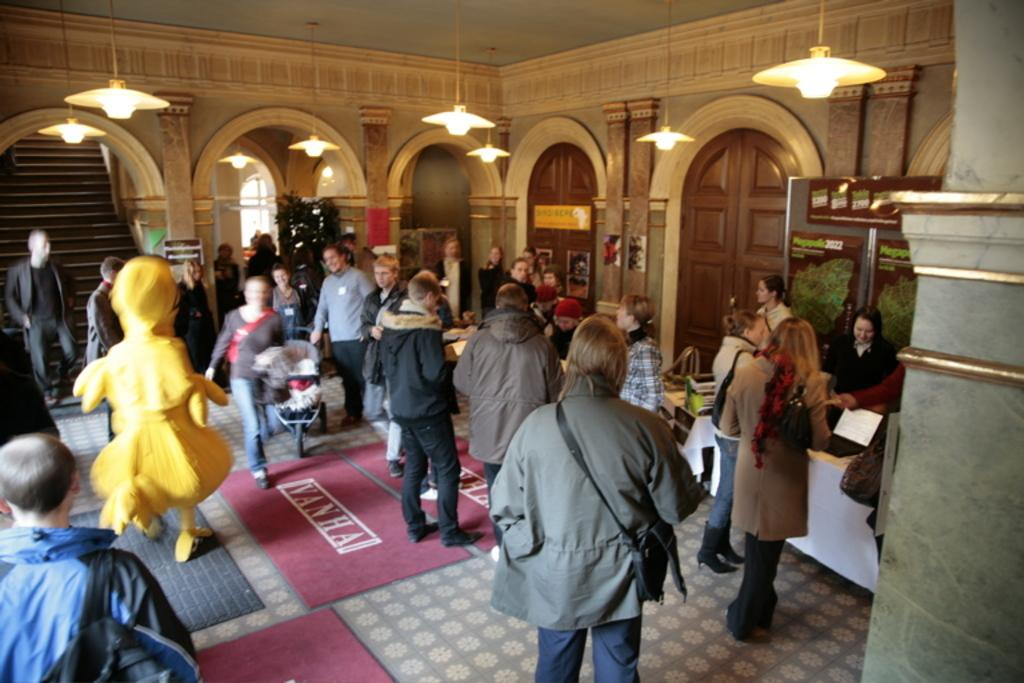How many people are in the image? There is a group of people in the image, but the exact number is not specified. What can be seen in the image besides the people? There is a stroller, carpets, lights, pillars, bags, doors, and unspecified objects in the background. What architectural feature is visible in the background of the image? There are steps visible in the background of the image. What type of toe is visible in the image? There is no toe visible in the image. Where is the home located in the image? The image does not depict a home; it shows a group of people, a stroller, carpets, lights, pillars, bags, doors, and unspecified objects in the background. 